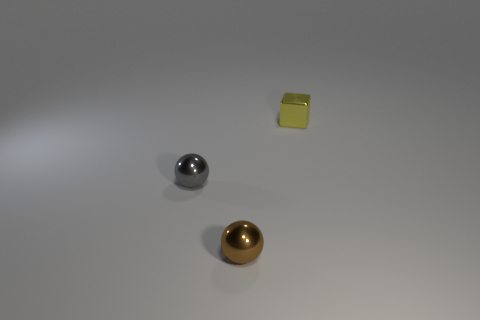Add 1 tiny yellow blocks. How many objects exist? 4 Subtract all blocks. How many objects are left? 2 Subtract 0 blue cubes. How many objects are left? 3 Subtract all gray blocks. Subtract all gray metallic balls. How many objects are left? 2 Add 3 tiny brown shiny objects. How many tiny brown shiny objects are left? 4 Add 3 red metallic objects. How many red metallic objects exist? 3 